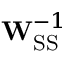<formula> <loc_0><loc_0><loc_500><loc_500>W _ { S S } ^ { - 1 }</formula> 